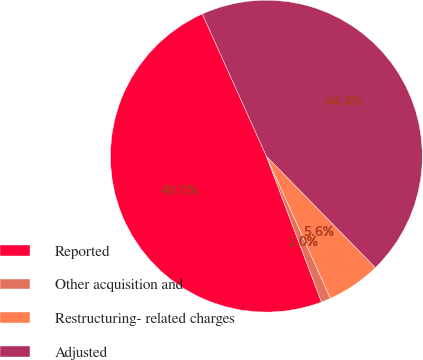<chart> <loc_0><loc_0><loc_500><loc_500><pie_chart><fcel>Reported<fcel>Other acquisition and<fcel>Restructuring- related charges<fcel>Adjusted<nl><fcel>49.01%<fcel>0.99%<fcel>5.59%<fcel>44.41%<nl></chart> 